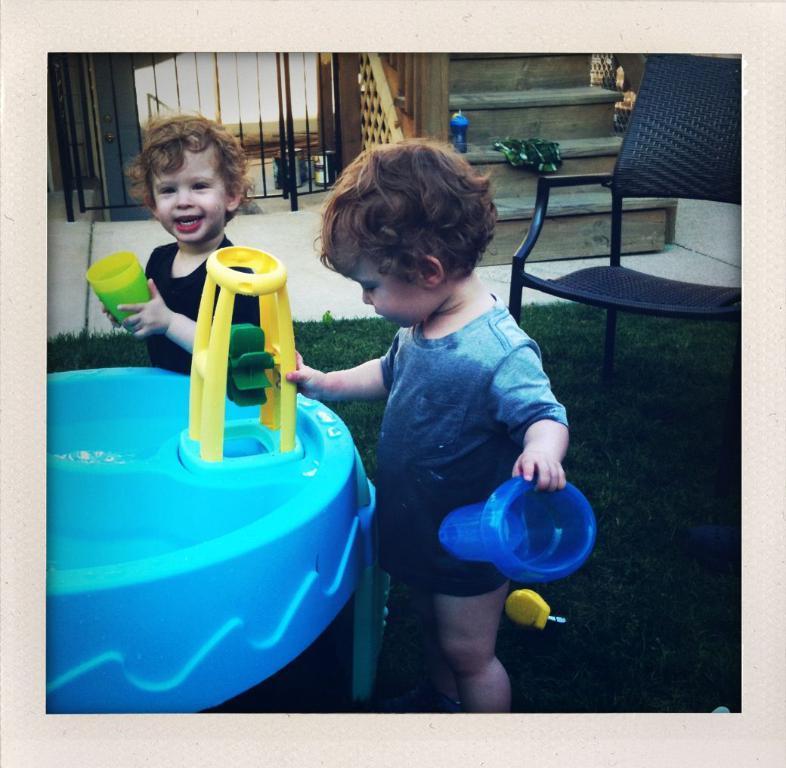Please provide a concise description of this image. In the picture we can see two children are standing on the green color mat and near to them, we can see a blue color playing object and they are holding it behind them and we can see a chair and beside it we can see a floor with some steps and railing to it. 